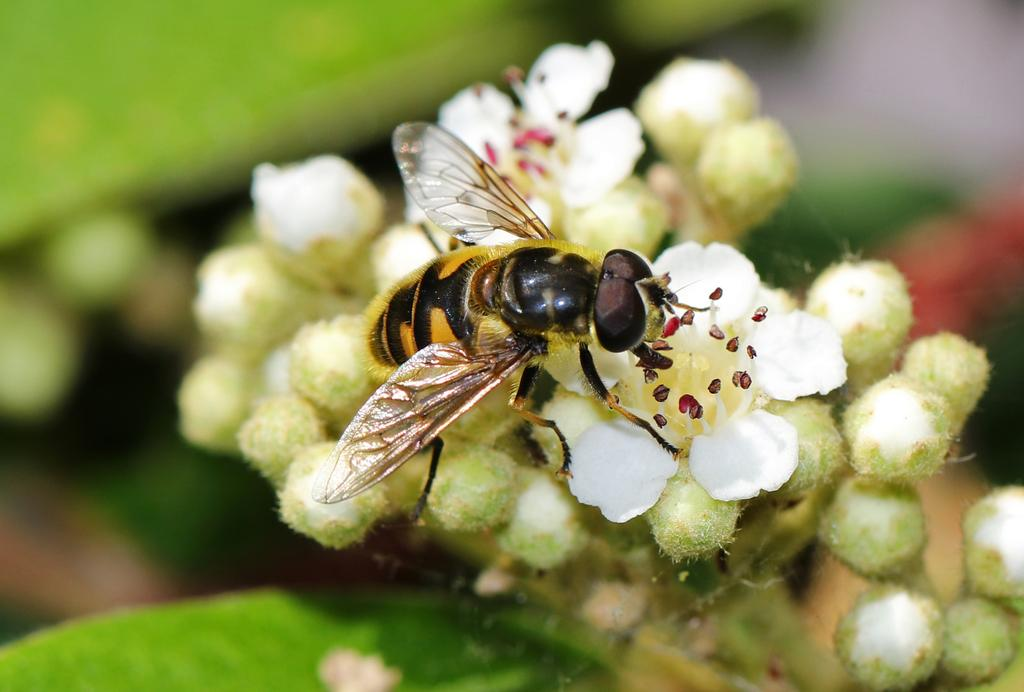What type of living organisms can be seen in the image? There are flowers and a honey bee in the image. What is the appearance of the background in the image? The background has a blurred view. What color is present in the image? The color green is present in the image. What type of suit is the honey bee wearing in the image? There is no suit present in the image, as honey bees do not wear clothing. 